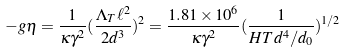<formula> <loc_0><loc_0><loc_500><loc_500>- g \eta = \frac { 1 } { \kappa \gamma ^ { 2 } } ( \frac { \Lambda _ { T } \ell ^ { 2 } } { 2 d ^ { 3 } } ) ^ { 2 } = \frac { 1 . 8 1 \times 1 0 ^ { 6 } } { \kappa \gamma ^ { 2 } } ( \frac { 1 } { H T d ^ { 4 } / d _ { 0 } } ) ^ { 1 / 2 }</formula> 